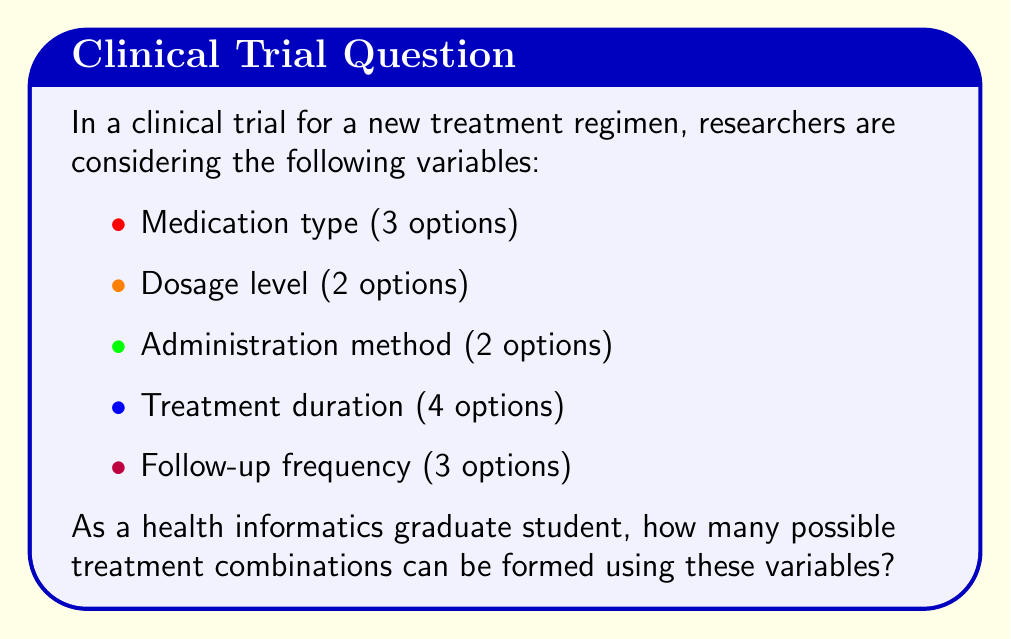Give your solution to this math problem. To solve this problem, we'll use the multiplication principle of counting. This principle states that if we have $n$ independent events, and each event $i$ has $m_i$ possible outcomes, then the total number of possible outcomes for all events is the product of the number of possibilities for each event.

Let's break down the problem step-by-step:

1. Medication type: 3 options
2. Dosage level: 2 options
3. Administration method: 2 options
4. Treatment duration: 4 options
5. Follow-up frequency: 3 options

To calculate the total number of possible combinations, we multiply the number of options for each variable:

$$ \text{Total combinations} = 3 \times 2 \times 2 \times 4 \times 3 $$

Calculating this:
$$ \text{Total combinations} = 3 \times 2 \times 2 \times 4 \times 3 = 144 $$

Therefore, there are 144 possible treatment combinations that can be formed using these variables in the clinical trial.

This calculation is important in health informatics as it helps researchers design and analyze clinical trials efficiently, ensuring that all possible combinations are considered and that the trial is comprehensive enough to draw meaningful conclusions.
Answer: 144 